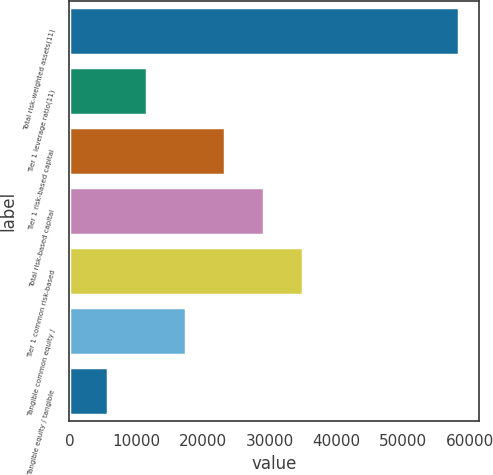Convert chart to OTSL. <chart><loc_0><loc_0><loc_500><loc_500><bar_chart><fcel>Total risk-weighted assets(11)<fcel>Tier 1 leverage ratio(11)<fcel>Tier 1 risk-based capital<fcel>Total risk-based capital<fcel>Tier 1 common risk-based<fcel>Tangible common equity /<fcel>Tangible equity / tangible<nl><fcel>58420<fcel>11690.2<fcel>23372.7<fcel>29213.9<fcel>35055.1<fcel>17531.5<fcel>5849.03<nl></chart> 